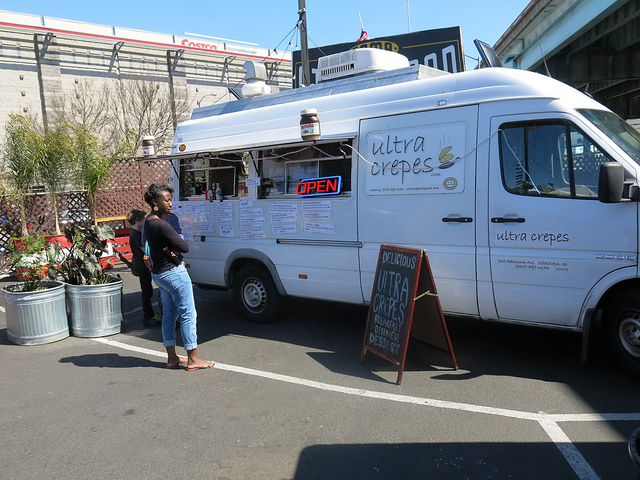How many potted plants are visible? 2 